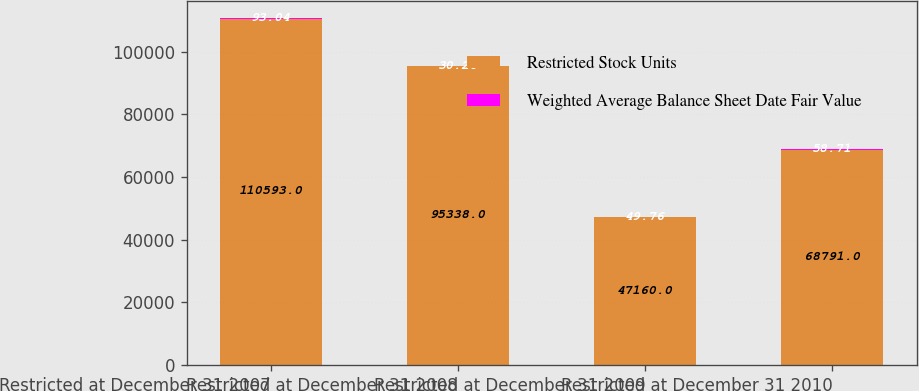Convert chart to OTSL. <chart><loc_0><loc_0><loc_500><loc_500><stacked_bar_chart><ecel><fcel>Restricted at December 31 2007<fcel>Restricted at December 31 2008<fcel>Restricted at December 31 2009<fcel>Restricted at December 31 2010<nl><fcel>Restricted Stock Units<fcel>110593<fcel>95338<fcel>47160<fcel>68791<nl><fcel>Weighted Average Balance Sheet Date Fair Value<fcel>93.04<fcel>30.26<fcel>49.76<fcel>58.71<nl></chart> 